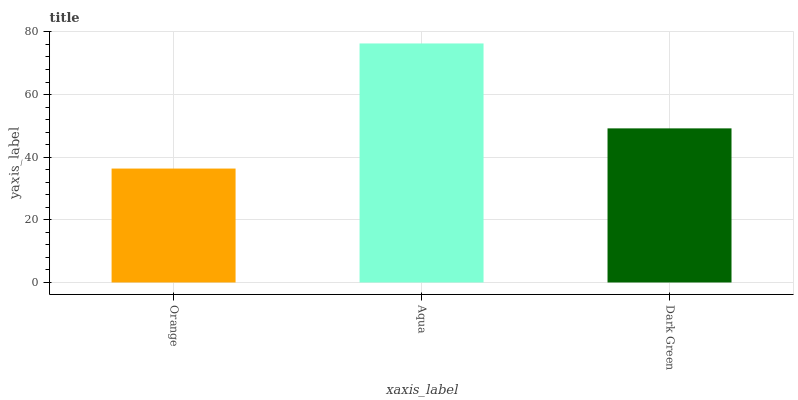Is Orange the minimum?
Answer yes or no. Yes. Is Aqua the maximum?
Answer yes or no. Yes. Is Dark Green the minimum?
Answer yes or no. No. Is Dark Green the maximum?
Answer yes or no. No. Is Aqua greater than Dark Green?
Answer yes or no. Yes. Is Dark Green less than Aqua?
Answer yes or no. Yes. Is Dark Green greater than Aqua?
Answer yes or no. No. Is Aqua less than Dark Green?
Answer yes or no. No. Is Dark Green the high median?
Answer yes or no. Yes. Is Dark Green the low median?
Answer yes or no. Yes. Is Aqua the high median?
Answer yes or no. No. Is Orange the low median?
Answer yes or no. No. 